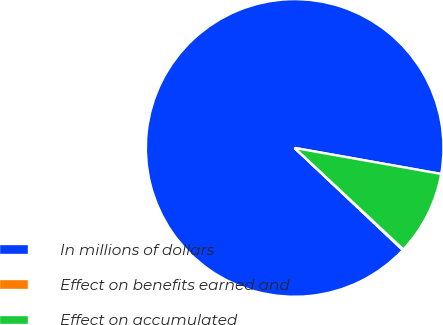<chart> <loc_0><loc_0><loc_500><loc_500><pie_chart><fcel>In millions of dollars<fcel>Effect on benefits earned and<fcel>Effect on accumulated<nl><fcel>90.75%<fcel>0.09%<fcel>9.16%<nl></chart> 